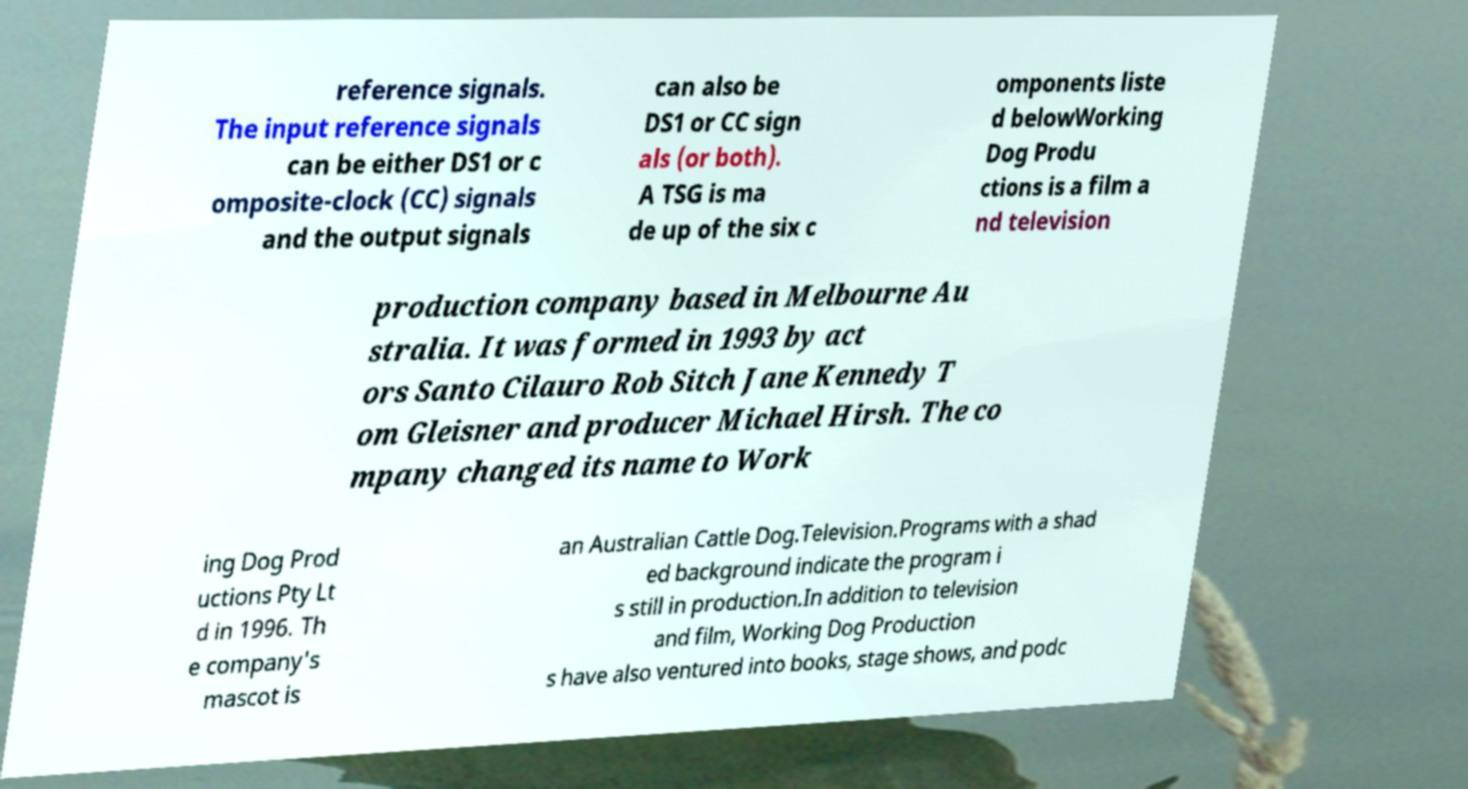Can you accurately transcribe the text from the provided image for me? reference signals. The input reference signals can be either DS1 or c omposite-clock (CC) signals and the output signals can also be DS1 or CC sign als (or both). A TSG is ma de up of the six c omponents liste d belowWorking Dog Produ ctions is a film a nd television production company based in Melbourne Au stralia. It was formed in 1993 by act ors Santo Cilauro Rob Sitch Jane Kennedy T om Gleisner and producer Michael Hirsh. The co mpany changed its name to Work ing Dog Prod uctions Pty Lt d in 1996. Th e company's mascot is an Australian Cattle Dog.Television.Programs with a shad ed background indicate the program i s still in production.In addition to television and film, Working Dog Production s have also ventured into books, stage shows, and podc 